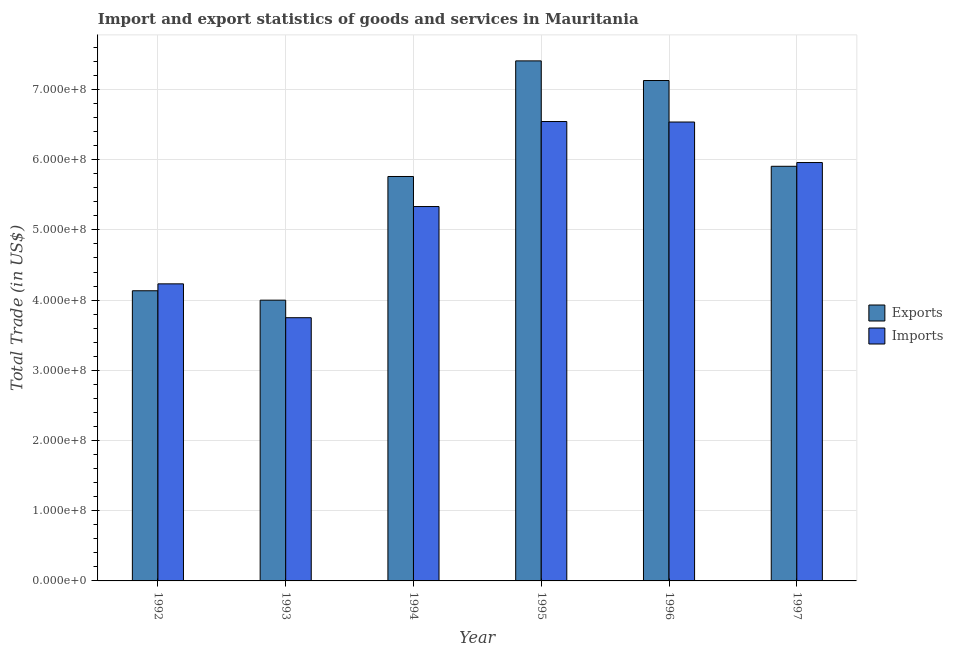How many groups of bars are there?
Ensure brevity in your answer.  6. Are the number of bars per tick equal to the number of legend labels?
Give a very brief answer. Yes. Are the number of bars on each tick of the X-axis equal?
Give a very brief answer. Yes. What is the imports of goods and services in 1992?
Keep it short and to the point. 4.23e+08. Across all years, what is the maximum imports of goods and services?
Your answer should be compact. 6.54e+08. Across all years, what is the minimum imports of goods and services?
Ensure brevity in your answer.  3.75e+08. In which year was the export of goods and services minimum?
Keep it short and to the point. 1993. What is the total imports of goods and services in the graph?
Keep it short and to the point. 3.24e+09. What is the difference between the export of goods and services in 1994 and that in 1997?
Offer a terse response. -1.45e+07. What is the difference between the export of goods and services in 1994 and the imports of goods and services in 1993?
Your answer should be compact. 1.76e+08. What is the average imports of goods and services per year?
Give a very brief answer. 5.39e+08. In how many years, is the export of goods and services greater than 320000000 US$?
Ensure brevity in your answer.  6. What is the ratio of the export of goods and services in 1994 to that in 1997?
Make the answer very short. 0.98. What is the difference between the highest and the second highest export of goods and services?
Your answer should be compact. 2.80e+07. What is the difference between the highest and the lowest imports of goods and services?
Your answer should be compact. 2.79e+08. What does the 2nd bar from the left in 1994 represents?
Give a very brief answer. Imports. What does the 2nd bar from the right in 1993 represents?
Your response must be concise. Exports. Are the values on the major ticks of Y-axis written in scientific E-notation?
Your answer should be compact. Yes. Does the graph contain grids?
Ensure brevity in your answer.  Yes. How are the legend labels stacked?
Your answer should be very brief. Vertical. What is the title of the graph?
Your answer should be compact. Import and export statistics of goods and services in Mauritania. What is the label or title of the Y-axis?
Provide a succinct answer. Total Trade (in US$). What is the Total Trade (in US$) in Exports in 1992?
Make the answer very short. 4.13e+08. What is the Total Trade (in US$) of Imports in 1992?
Your answer should be very brief. 4.23e+08. What is the Total Trade (in US$) in Exports in 1993?
Your answer should be compact. 4.00e+08. What is the Total Trade (in US$) in Imports in 1993?
Your answer should be compact. 3.75e+08. What is the Total Trade (in US$) of Exports in 1994?
Offer a very short reply. 5.76e+08. What is the Total Trade (in US$) of Imports in 1994?
Make the answer very short. 5.33e+08. What is the Total Trade (in US$) of Exports in 1995?
Your answer should be very brief. 7.41e+08. What is the Total Trade (in US$) of Imports in 1995?
Offer a very short reply. 6.54e+08. What is the Total Trade (in US$) in Exports in 1996?
Keep it short and to the point. 7.13e+08. What is the Total Trade (in US$) in Imports in 1996?
Provide a succinct answer. 6.54e+08. What is the Total Trade (in US$) of Exports in 1997?
Make the answer very short. 5.91e+08. What is the Total Trade (in US$) in Imports in 1997?
Keep it short and to the point. 5.96e+08. Across all years, what is the maximum Total Trade (in US$) in Exports?
Provide a succinct answer. 7.41e+08. Across all years, what is the maximum Total Trade (in US$) of Imports?
Your answer should be very brief. 6.54e+08. Across all years, what is the minimum Total Trade (in US$) in Exports?
Make the answer very short. 4.00e+08. Across all years, what is the minimum Total Trade (in US$) in Imports?
Your answer should be very brief. 3.75e+08. What is the total Total Trade (in US$) of Exports in the graph?
Keep it short and to the point. 3.43e+09. What is the total Total Trade (in US$) of Imports in the graph?
Offer a very short reply. 3.24e+09. What is the difference between the Total Trade (in US$) of Exports in 1992 and that in 1993?
Your answer should be very brief. 1.34e+07. What is the difference between the Total Trade (in US$) of Imports in 1992 and that in 1993?
Provide a short and direct response. 4.82e+07. What is the difference between the Total Trade (in US$) of Exports in 1992 and that in 1994?
Offer a very short reply. -1.63e+08. What is the difference between the Total Trade (in US$) in Imports in 1992 and that in 1994?
Make the answer very short. -1.10e+08. What is the difference between the Total Trade (in US$) in Exports in 1992 and that in 1995?
Offer a terse response. -3.27e+08. What is the difference between the Total Trade (in US$) of Imports in 1992 and that in 1995?
Offer a very short reply. -2.31e+08. What is the difference between the Total Trade (in US$) in Exports in 1992 and that in 1996?
Offer a very short reply. -2.99e+08. What is the difference between the Total Trade (in US$) of Imports in 1992 and that in 1996?
Ensure brevity in your answer.  -2.30e+08. What is the difference between the Total Trade (in US$) of Exports in 1992 and that in 1997?
Make the answer very short. -1.77e+08. What is the difference between the Total Trade (in US$) in Imports in 1992 and that in 1997?
Provide a short and direct response. -1.73e+08. What is the difference between the Total Trade (in US$) of Exports in 1993 and that in 1994?
Ensure brevity in your answer.  -1.76e+08. What is the difference between the Total Trade (in US$) of Imports in 1993 and that in 1994?
Keep it short and to the point. -1.58e+08. What is the difference between the Total Trade (in US$) of Exports in 1993 and that in 1995?
Your response must be concise. -3.41e+08. What is the difference between the Total Trade (in US$) in Imports in 1993 and that in 1995?
Your answer should be compact. -2.79e+08. What is the difference between the Total Trade (in US$) of Exports in 1993 and that in 1996?
Your response must be concise. -3.13e+08. What is the difference between the Total Trade (in US$) in Imports in 1993 and that in 1996?
Your response must be concise. -2.79e+08. What is the difference between the Total Trade (in US$) of Exports in 1993 and that in 1997?
Make the answer very short. -1.91e+08. What is the difference between the Total Trade (in US$) of Imports in 1993 and that in 1997?
Your answer should be compact. -2.21e+08. What is the difference between the Total Trade (in US$) in Exports in 1994 and that in 1995?
Give a very brief answer. -1.65e+08. What is the difference between the Total Trade (in US$) of Imports in 1994 and that in 1995?
Offer a terse response. -1.21e+08. What is the difference between the Total Trade (in US$) in Exports in 1994 and that in 1996?
Your answer should be very brief. -1.37e+08. What is the difference between the Total Trade (in US$) in Imports in 1994 and that in 1996?
Your answer should be very brief. -1.20e+08. What is the difference between the Total Trade (in US$) in Exports in 1994 and that in 1997?
Keep it short and to the point. -1.45e+07. What is the difference between the Total Trade (in US$) in Imports in 1994 and that in 1997?
Provide a short and direct response. -6.27e+07. What is the difference between the Total Trade (in US$) in Exports in 1995 and that in 1996?
Your answer should be compact. 2.80e+07. What is the difference between the Total Trade (in US$) of Imports in 1995 and that in 1996?
Your response must be concise. 7.04e+05. What is the difference between the Total Trade (in US$) of Exports in 1995 and that in 1997?
Ensure brevity in your answer.  1.50e+08. What is the difference between the Total Trade (in US$) in Imports in 1995 and that in 1997?
Provide a succinct answer. 5.84e+07. What is the difference between the Total Trade (in US$) in Exports in 1996 and that in 1997?
Keep it short and to the point. 1.22e+08. What is the difference between the Total Trade (in US$) in Imports in 1996 and that in 1997?
Make the answer very short. 5.77e+07. What is the difference between the Total Trade (in US$) of Exports in 1992 and the Total Trade (in US$) of Imports in 1993?
Offer a very short reply. 3.84e+07. What is the difference between the Total Trade (in US$) in Exports in 1992 and the Total Trade (in US$) in Imports in 1994?
Offer a very short reply. -1.20e+08. What is the difference between the Total Trade (in US$) of Exports in 1992 and the Total Trade (in US$) of Imports in 1995?
Keep it short and to the point. -2.41e+08. What is the difference between the Total Trade (in US$) in Exports in 1992 and the Total Trade (in US$) in Imports in 1996?
Your answer should be compact. -2.40e+08. What is the difference between the Total Trade (in US$) of Exports in 1992 and the Total Trade (in US$) of Imports in 1997?
Provide a short and direct response. -1.83e+08. What is the difference between the Total Trade (in US$) in Exports in 1993 and the Total Trade (in US$) in Imports in 1994?
Give a very brief answer. -1.33e+08. What is the difference between the Total Trade (in US$) of Exports in 1993 and the Total Trade (in US$) of Imports in 1995?
Keep it short and to the point. -2.54e+08. What is the difference between the Total Trade (in US$) of Exports in 1993 and the Total Trade (in US$) of Imports in 1996?
Offer a very short reply. -2.54e+08. What is the difference between the Total Trade (in US$) of Exports in 1993 and the Total Trade (in US$) of Imports in 1997?
Provide a succinct answer. -1.96e+08. What is the difference between the Total Trade (in US$) of Exports in 1994 and the Total Trade (in US$) of Imports in 1995?
Your answer should be very brief. -7.83e+07. What is the difference between the Total Trade (in US$) in Exports in 1994 and the Total Trade (in US$) in Imports in 1996?
Ensure brevity in your answer.  -7.76e+07. What is the difference between the Total Trade (in US$) of Exports in 1994 and the Total Trade (in US$) of Imports in 1997?
Ensure brevity in your answer.  -1.99e+07. What is the difference between the Total Trade (in US$) in Exports in 1995 and the Total Trade (in US$) in Imports in 1996?
Your answer should be compact. 8.71e+07. What is the difference between the Total Trade (in US$) in Exports in 1995 and the Total Trade (in US$) in Imports in 1997?
Your answer should be very brief. 1.45e+08. What is the difference between the Total Trade (in US$) of Exports in 1996 and the Total Trade (in US$) of Imports in 1997?
Keep it short and to the point. 1.17e+08. What is the average Total Trade (in US$) in Exports per year?
Give a very brief answer. 5.72e+08. What is the average Total Trade (in US$) of Imports per year?
Your answer should be very brief. 5.39e+08. In the year 1992, what is the difference between the Total Trade (in US$) of Exports and Total Trade (in US$) of Imports?
Offer a very short reply. -9.83e+06. In the year 1993, what is the difference between the Total Trade (in US$) of Exports and Total Trade (in US$) of Imports?
Your answer should be very brief. 2.50e+07. In the year 1994, what is the difference between the Total Trade (in US$) of Exports and Total Trade (in US$) of Imports?
Your response must be concise. 4.28e+07. In the year 1995, what is the difference between the Total Trade (in US$) in Exports and Total Trade (in US$) in Imports?
Offer a terse response. 8.64e+07. In the year 1996, what is the difference between the Total Trade (in US$) of Exports and Total Trade (in US$) of Imports?
Provide a short and direct response. 5.91e+07. In the year 1997, what is the difference between the Total Trade (in US$) in Exports and Total Trade (in US$) in Imports?
Your response must be concise. -5.35e+06. What is the ratio of the Total Trade (in US$) of Exports in 1992 to that in 1993?
Your answer should be compact. 1.03. What is the ratio of the Total Trade (in US$) in Imports in 1992 to that in 1993?
Give a very brief answer. 1.13. What is the ratio of the Total Trade (in US$) in Exports in 1992 to that in 1994?
Give a very brief answer. 0.72. What is the ratio of the Total Trade (in US$) in Imports in 1992 to that in 1994?
Make the answer very short. 0.79. What is the ratio of the Total Trade (in US$) in Exports in 1992 to that in 1995?
Offer a terse response. 0.56. What is the ratio of the Total Trade (in US$) of Imports in 1992 to that in 1995?
Ensure brevity in your answer.  0.65. What is the ratio of the Total Trade (in US$) in Exports in 1992 to that in 1996?
Offer a terse response. 0.58. What is the ratio of the Total Trade (in US$) of Imports in 1992 to that in 1996?
Your answer should be very brief. 0.65. What is the ratio of the Total Trade (in US$) in Exports in 1992 to that in 1997?
Provide a short and direct response. 0.7. What is the ratio of the Total Trade (in US$) of Imports in 1992 to that in 1997?
Your answer should be very brief. 0.71. What is the ratio of the Total Trade (in US$) in Exports in 1993 to that in 1994?
Offer a very short reply. 0.69. What is the ratio of the Total Trade (in US$) of Imports in 1993 to that in 1994?
Your response must be concise. 0.7. What is the ratio of the Total Trade (in US$) of Exports in 1993 to that in 1995?
Give a very brief answer. 0.54. What is the ratio of the Total Trade (in US$) in Imports in 1993 to that in 1995?
Offer a very short reply. 0.57. What is the ratio of the Total Trade (in US$) of Exports in 1993 to that in 1996?
Your answer should be very brief. 0.56. What is the ratio of the Total Trade (in US$) in Imports in 1993 to that in 1996?
Give a very brief answer. 0.57. What is the ratio of the Total Trade (in US$) in Exports in 1993 to that in 1997?
Your answer should be compact. 0.68. What is the ratio of the Total Trade (in US$) of Imports in 1993 to that in 1997?
Offer a terse response. 0.63. What is the ratio of the Total Trade (in US$) of Exports in 1994 to that in 1995?
Offer a terse response. 0.78. What is the ratio of the Total Trade (in US$) in Imports in 1994 to that in 1995?
Keep it short and to the point. 0.81. What is the ratio of the Total Trade (in US$) of Exports in 1994 to that in 1996?
Your answer should be compact. 0.81. What is the ratio of the Total Trade (in US$) of Imports in 1994 to that in 1996?
Offer a very short reply. 0.82. What is the ratio of the Total Trade (in US$) in Exports in 1994 to that in 1997?
Your answer should be compact. 0.98. What is the ratio of the Total Trade (in US$) of Imports in 1994 to that in 1997?
Offer a terse response. 0.89. What is the ratio of the Total Trade (in US$) in Exports in 1995 to that in 1996?
Offer a very short reply. 1.04. What is the ratio of the Total Trade (in US$) of Imports in 1995 to that in 1996?
Offer a terse response. 1. What is the ratio of the Total Trade (in US$) of Exports in 1995 to that in 1997?
Provide a succinct answer. 1.25. What is the ratio of the Total Trade (in US$) of Imports in 1995 to that in 1997?
Your answer should be compact. 1.1. What is the ratio of the Total Trade (in US$) of Exports in 1996 to that in 1997?
Give a very brief answer. 1.21. What is the ratio of the Total Trade (in US$) in Imports in 1996 to that in 1997?
Offer a very short reply. 1.1. What is the difference between the highest and the second highest Total Trade (in US$) in Exports?
Give a very brief answer. 2.80e+07. What is the difference between the highest and the second highest Total Trade (in US$) of Imports?
Offer a terse response. 7.04e+05. What is the difference between the highest and the lowest Total Trade (in US$) in Exports?
Provide a succinct answer. 3.41e+08. What is the difference between the highest and the lowest Total Trade (in US$) in Imports?
Give a very brief answer. 2.79e+08. 